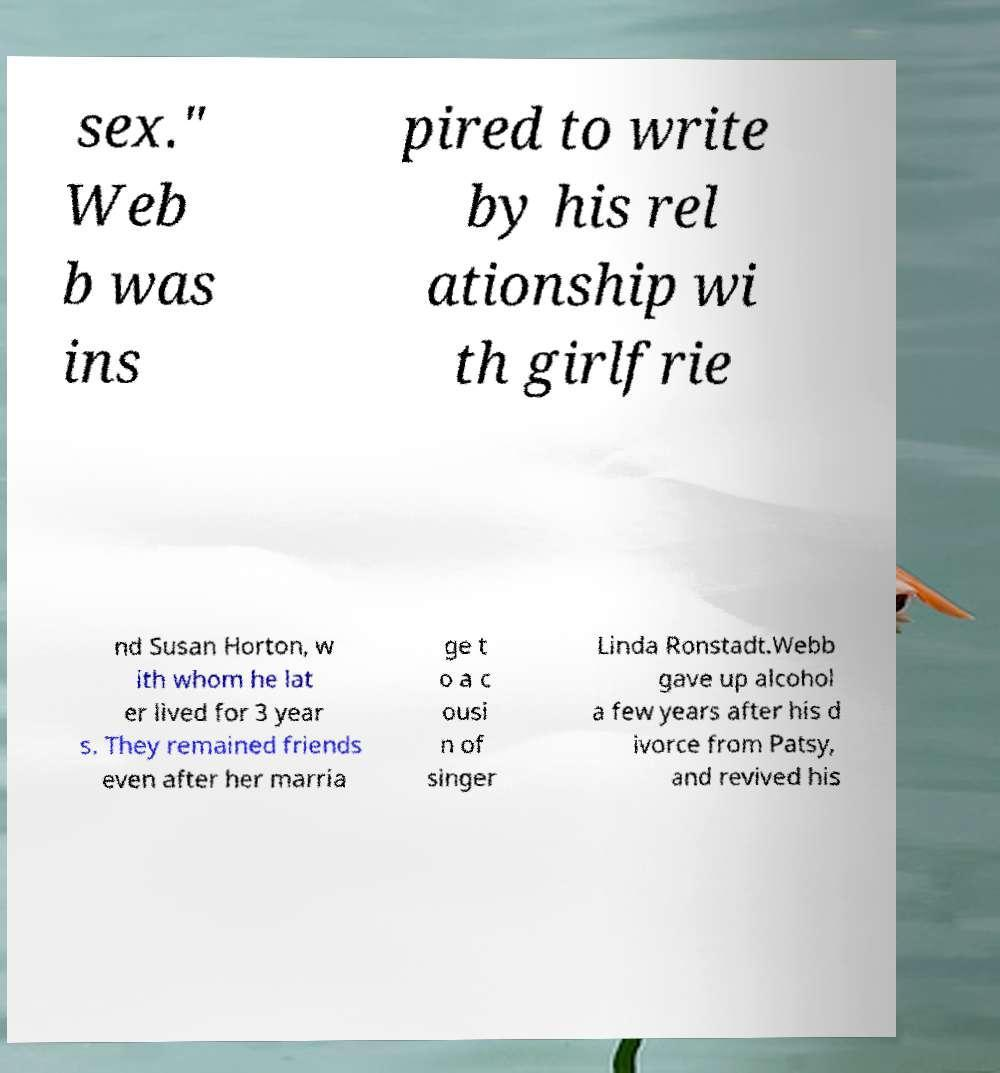What messages or text are displayed in this image? I need them in a readable, typed format. sex." Web b was ins pired to write by his rel ationship wi th girlfrie nd Susan Horton, w ith whom he lat er lived for 3 year s. They remained friends even after her marria ge t o a c ousi n of singer Linda Ronstadt.Webb gave up alcohol a few years after his d ivorce from Patsy, and revived his 